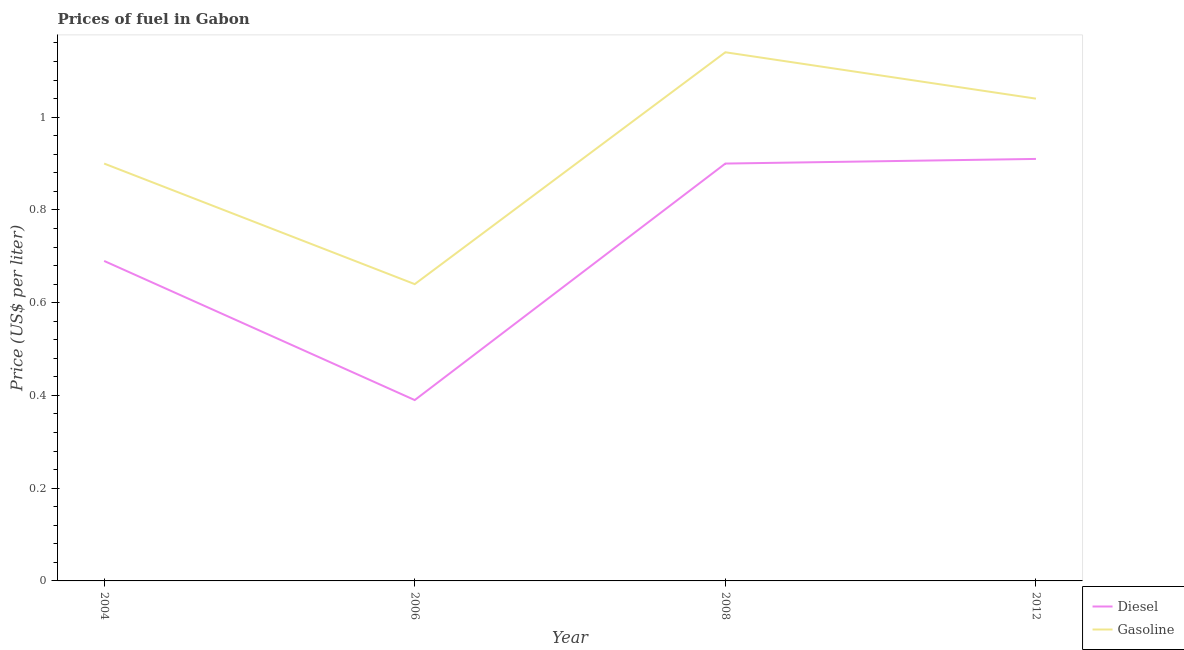What is the gasoline price in 2006?
Ensure brevity in your answer.  0.64. Across all years, what is the maximum gasoline price?
Your answer should be very brief. 1.14. Across all years, what is the minimum gasoline price?
Your answer should be very brief. 0.64. In which year was the diesel price minimum?
Your answer should be compact. 2006. What is the total diesel price in the graph?
Give a very brief answer. 2.89. What is the difference between the diesel price in 2004 and the gasoline price in 2008?
Provide a succinct answer. -0.45. What is the average gasoline price per year?
Ensure brevity in your answer.  0.93. In how many years, is the diesel price greater than 0.32 US$ per litre?
Ensure brevity in your answer.  4. What is the ratio of the diesel price in 2004 to that in 2008?
Your answer should be very brief. 0.77. Is the diesel price in 2004 less than that in 2006?
Offer a very short reply. No. What is the difference between the highest and the second highest diesel price?
Your answer should be very brief. 0.01. What is the difference between the highest and the lowest diesel price?
Offer a terse response. 0.52. In how many years, is the diesel price greater than the average diesel price taken over all years?
Offer a very short reply. 2. Is the sum of the gasoline price in 2008 and 2012 greater than the maximum diesel price across all years?
Keep it short and to the point. Yes. Does the diesel price monotonically increase over the years?
Your response must be concise. No. Is the diesel price strictly less than the gasoline price over the years?
Ensure brevity in your answer.  Yes. How many years are there in the graph?
Your answer should be compact. 4. What is the difference between two consecutive major ticks on the Y-axis?
Provide a short and direct response. 0.2. Are the values on the major ticks of Y-axis written in scientific E-notation?
Give a very brief answer. No. Does the graph contain grids?
Provide a short and direct response. No. Where does the legend appear in the graph?
Your answer should be compact. Bottom right. How many legend labels are there?
Keep it short and to the point. 2. How are the legend labels stacked?
Your answer should be very brief. Vertical. What is the title of the graph?
Your response must be concise. Prices of fuel in Gabon. What is the label or title of the X-axis?
Give a very brief answer. Year. What is the label or title of the Y-axis?
Offer a terse response. Price (US$ per liter). What is the Price (US$ per liter) in Diesel in 2004?
Ensure brevity in your answer.  0.69. What is the Price (US$ per liter) of Gasoline in 2004?
Offer a very short reply. 0.9. What is the Price (US$ per liter) of Diesel in 2006?
Your response must be concise. 0.39. What is the Price (US$ per liter) of Gasoline in 2006?
Your answer should be compact. 0.64. What is the Price (US$ per liter) of Diesel in 2008?
Keep it short and to the point. 0.9. What is the Price (US$ per liter) in Gasoline in 2008?
Ensure brevity in your answer.  1.14. What is the Price (US$ per liter) of Diesel in 2012?
Your response must be concise. 0.91. Across all years, what is the maximum Price (US$ per liter) in Diesel?
Your answer should be very brief. 0.91. Across all years, what is the maximum Price (US$ per liter) of Gasoline?
Provide a succinct answer. 1.14. Across all years, what is the minimum Price (US$ per liter) in Diesel?
Provide a short and direct response. 0.39. Across all years, what is the minimum Price (US$ per liter) in Gasoline?
Your answer should be compact. 0.64. What is the total Price (US$ per liter) of Diesel in the graph?
Your answer should be very brief. 2.89. What is the total Price (US$ per liter) of Gasoline in the graph?
Provide a short and direct response. 3.72. What is the difference between the Price (US$ per liter) of Gasoline in 2004 and that in 2006?
Offer a terse response. 0.26. What is the difference between the Price (US$ per liter) in Diesel in 2004 and that in 2008?
Your response must be concise. -0.21. What is the difference between the Price (US$ per liter) of Gasoline in 2004 and that in 2008?
Give a very brief answer. -0.24. What is the difference between the Price (US$ per liter) in Diesel in 2004 and that in 2012?
Make the answer very short. -0.22. What is the difference between the Price (US$ per liter) in Gasoline in 2004 and that in 2012?
Keep it short and to the point. -0.14. What is the difference between the Price (US$ per liter) in Diesel in 2006 and that in 2008?
Your answer should be compact. -0.51. What is the difference between the Price (US$ per liter) of Diesel in 2006 and that in 2012?
Your answer should be very brief. -0.52. What is the difference between the Price (US$ per liter) in Gasoline in 2006 and that in 2012?
Offer a very short reply. -0.4. What is the difference between the Price (US$ per liter) of Diesel in 2008 and that in 2012?
Keep it short and to the point. -0.01. What is the difference between the Price (US$ per liter) of Diesel in 2004 and the Price (US$ per liter) of Gasoline in 2008?
Ensure brevity in your answer.  -0.45. What is the difference between the Price (US$ per liter) in Diesel in 2004 and the Price (US$ per liter) in Gasoline in 2012?
Give a very brief answer. -0.35. What is the difference between the Price (US$ per liter) of Diesel in 2006 and the Price (US$ per liter) of Gasoline in 2008?
Give a very brief answer. -0.75. What is the difference between the Price (US$ per liter) of Diesel in 2006 and the Price (US$ per liter) of Gasoline in 2012?
Make the answer very short. -0.65. What is the difference between the Price (US$ per liter) in Diesel in 2008 and the Price (US$ per liter) in Gasoline in 2012?
Offer a terse response. -0.14. What is the average Price (US$ per liter) of Diesel per year?
Your answer should be compact. 0.72. What is the average Price (US$ per liter) in Gasoline per year?
Offer a terse response. 0.93. In the year 2004, what is the difference between the Price (US$ per liter) of Diesel and Price (US$ per liter) of Gasoline?
Offer a terse response. -0.21. In the year 2008, what is the difference between the Price (US$ per liter) in Diesel and Price (US$ per liter) in Gasoline?
Your response must be concise. -0.24. In the year 2012, what is the difference between the Price (US$ per liter) in Diesel and Price (US$ per liter) in Gasoline?
Keep it short and to the point. -0.13. What is the ratio of the Price (US$ per liter) of Diesel in 2004 to that in 2006?
Give a very brief answer. 1.77. What is the ratio of the Price (US$ per liter) in Gasoline in 2004 to that in 2006?
Provide a short and direct response. 1.41. What is the ratio of the Price (US$ per liter) of Diesel in 2004 to that in 2008?
Make the answer very short. 0.77. What is the ratio of the Price (US$ per liter) in Gasoline in 2004 to that in 2008?
Offer a very short reply. 0.79. What is the ratio of the Price (US$ per liter) of Diesel in 2004 to that in 2012?
Your answer should be compact. 0.76. What is the ratio of the Price (US$ per liter) in Gasoline in 2004 to that in 2012?
Ensure brevity in your answer.  0.87. What is the ratio of the Price (US$ per liter) of Diesel in 2006 to that in 2008?
Give a very brief answer. 0.43. What is the ratio of the Price (US$ per liter) in Gasoline in 2006 to that in 2008?
Provide a succinct answer. 0.56. What is the ratio of the Price (US$ per liter) of Diesel in 2006 to that in 2012?
Provide a short and direct response. 0.43. What is the ratio of the Price (US$ per liter) in Gasoline in 2006 to that in 2012?
Your answer should be very brief. 0.62. What is the ratio of the Price (US$ per liter) of Gasoline in 2008 to that in 2012?
Offer a very short reply. 1.1. What is the difference between the highest and the second highest Price (US$ per liter) of Gasoline?
Provide a short and direct response. 0.1. What is the difference between the highest and the lowest Price (US$ per liter) in Diesel?
Keep it short and to the point. 0.52. 